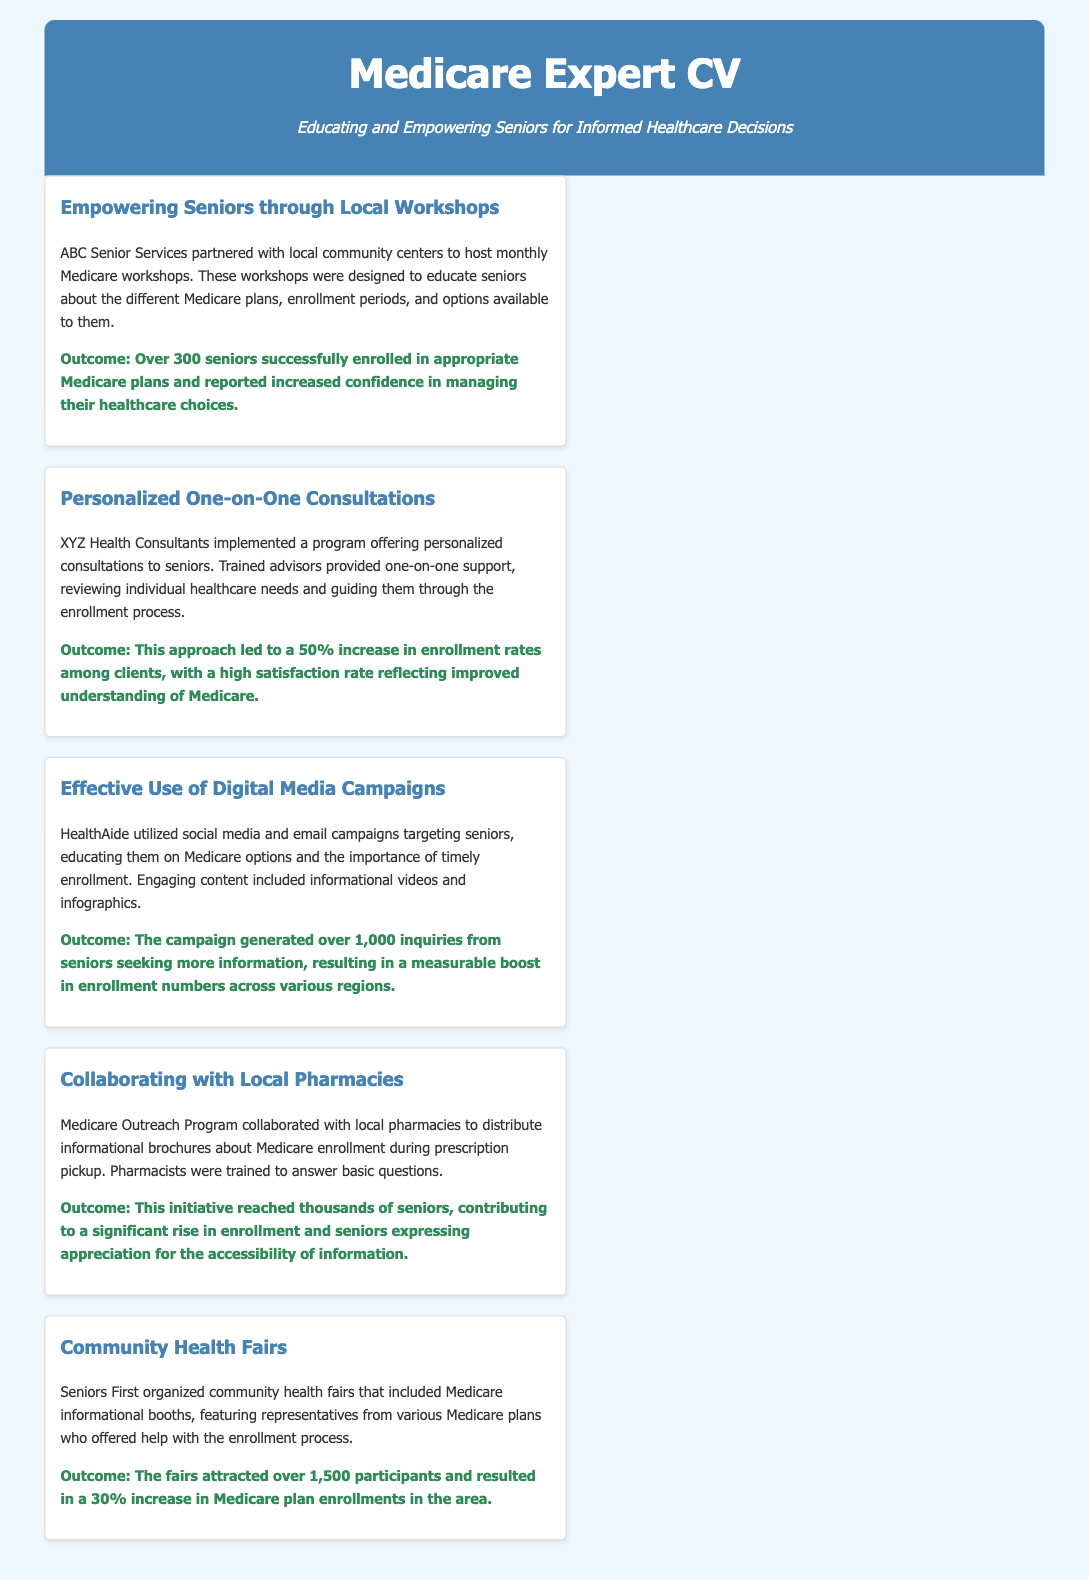What was the outcome of the monthly Medicare workshops? The outcome of the workshops was that over 300 seniors successfully enrolled in appropriate Medicare plans and reported increased confidence in managing their healthcare choices.
Answer: Over 300 seniors What program did XYZ Health Consultants implement? XYZ Health Consultants implemented a program offering personalized consultations to seniors to guide them through the enrollment process.
Answer: Personalized consultations How many inquiries did HealthAide's digital media campaigns generate? The campaigns generated over 1,000 inquiries from seniors seeking more information about Medicare options.
Answer: Over 1,000 inquiries What percentage increase in enrollments resulted from the community health fairs organized by Seniors First? The health fairs resulted in a 30% increase in Medicare plan enrollments in the area.
Answer: 30% Which organization collaborated with local pharmacies for Medicare enrollment? The Medicare Outreach Program collaborated with local pharmacies to distribute informational brochures about Medicare enrollment.
Answer: Medicare Outreach Program What is a unique feature of the workshops hosted by ABC Senior Services? The workshops were designed to educate seniors about the different Medicare plans, enrollment periods, and options available to them.
Answer: Educate seniors What is the main goal of case studies mentioned in the document? The main goal of the case studies is to present successful strategies for Medicare enrollment among seniors.
Answer: Successful strategies What type of content did HealthAide use in their digital media campaigns? Engaging content included informational videos and infographics targeting seniors about Medicare options.
Answer: Informational videos and infographics 